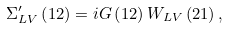Convert formula to latex. <formula><loc_0><loc_0><loc_500><loc_500>\Sigma _ { L V } ^ { \prime } \left ( 1 2 \right ) = i G \left ( 1 2 \right ) W _ { L V } \left ( 2 1 \right ) ,</formula> 